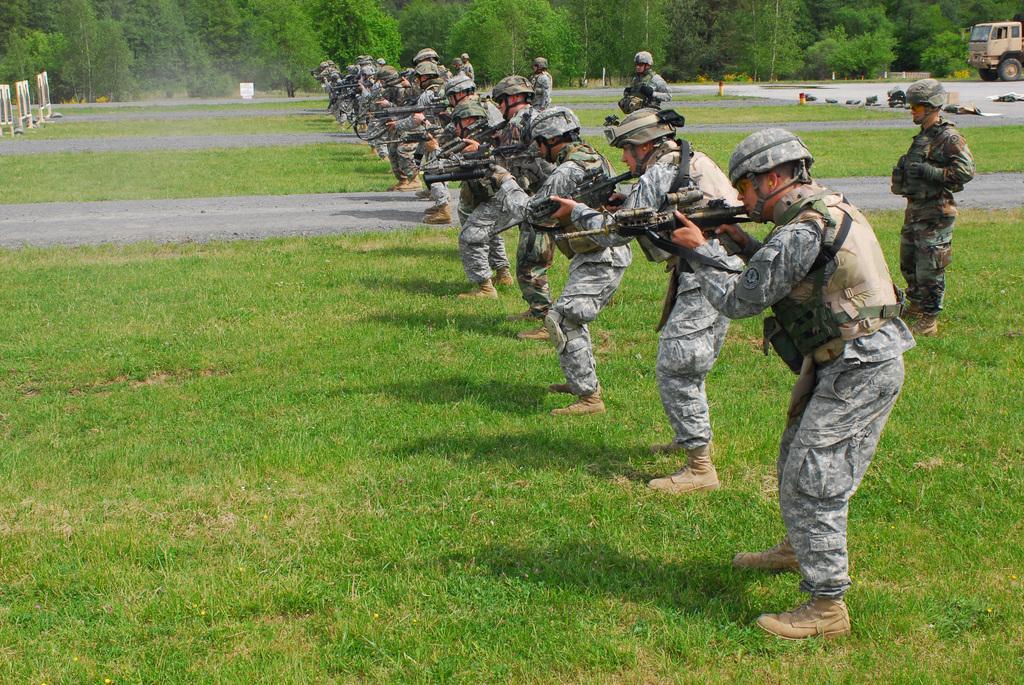Can you describe this image briefly? In this image we can see people standing. They are wearing uniforms and holding rifles. At the bottom there is grass. In the background there are trees and we can see a vehicle on the road. 